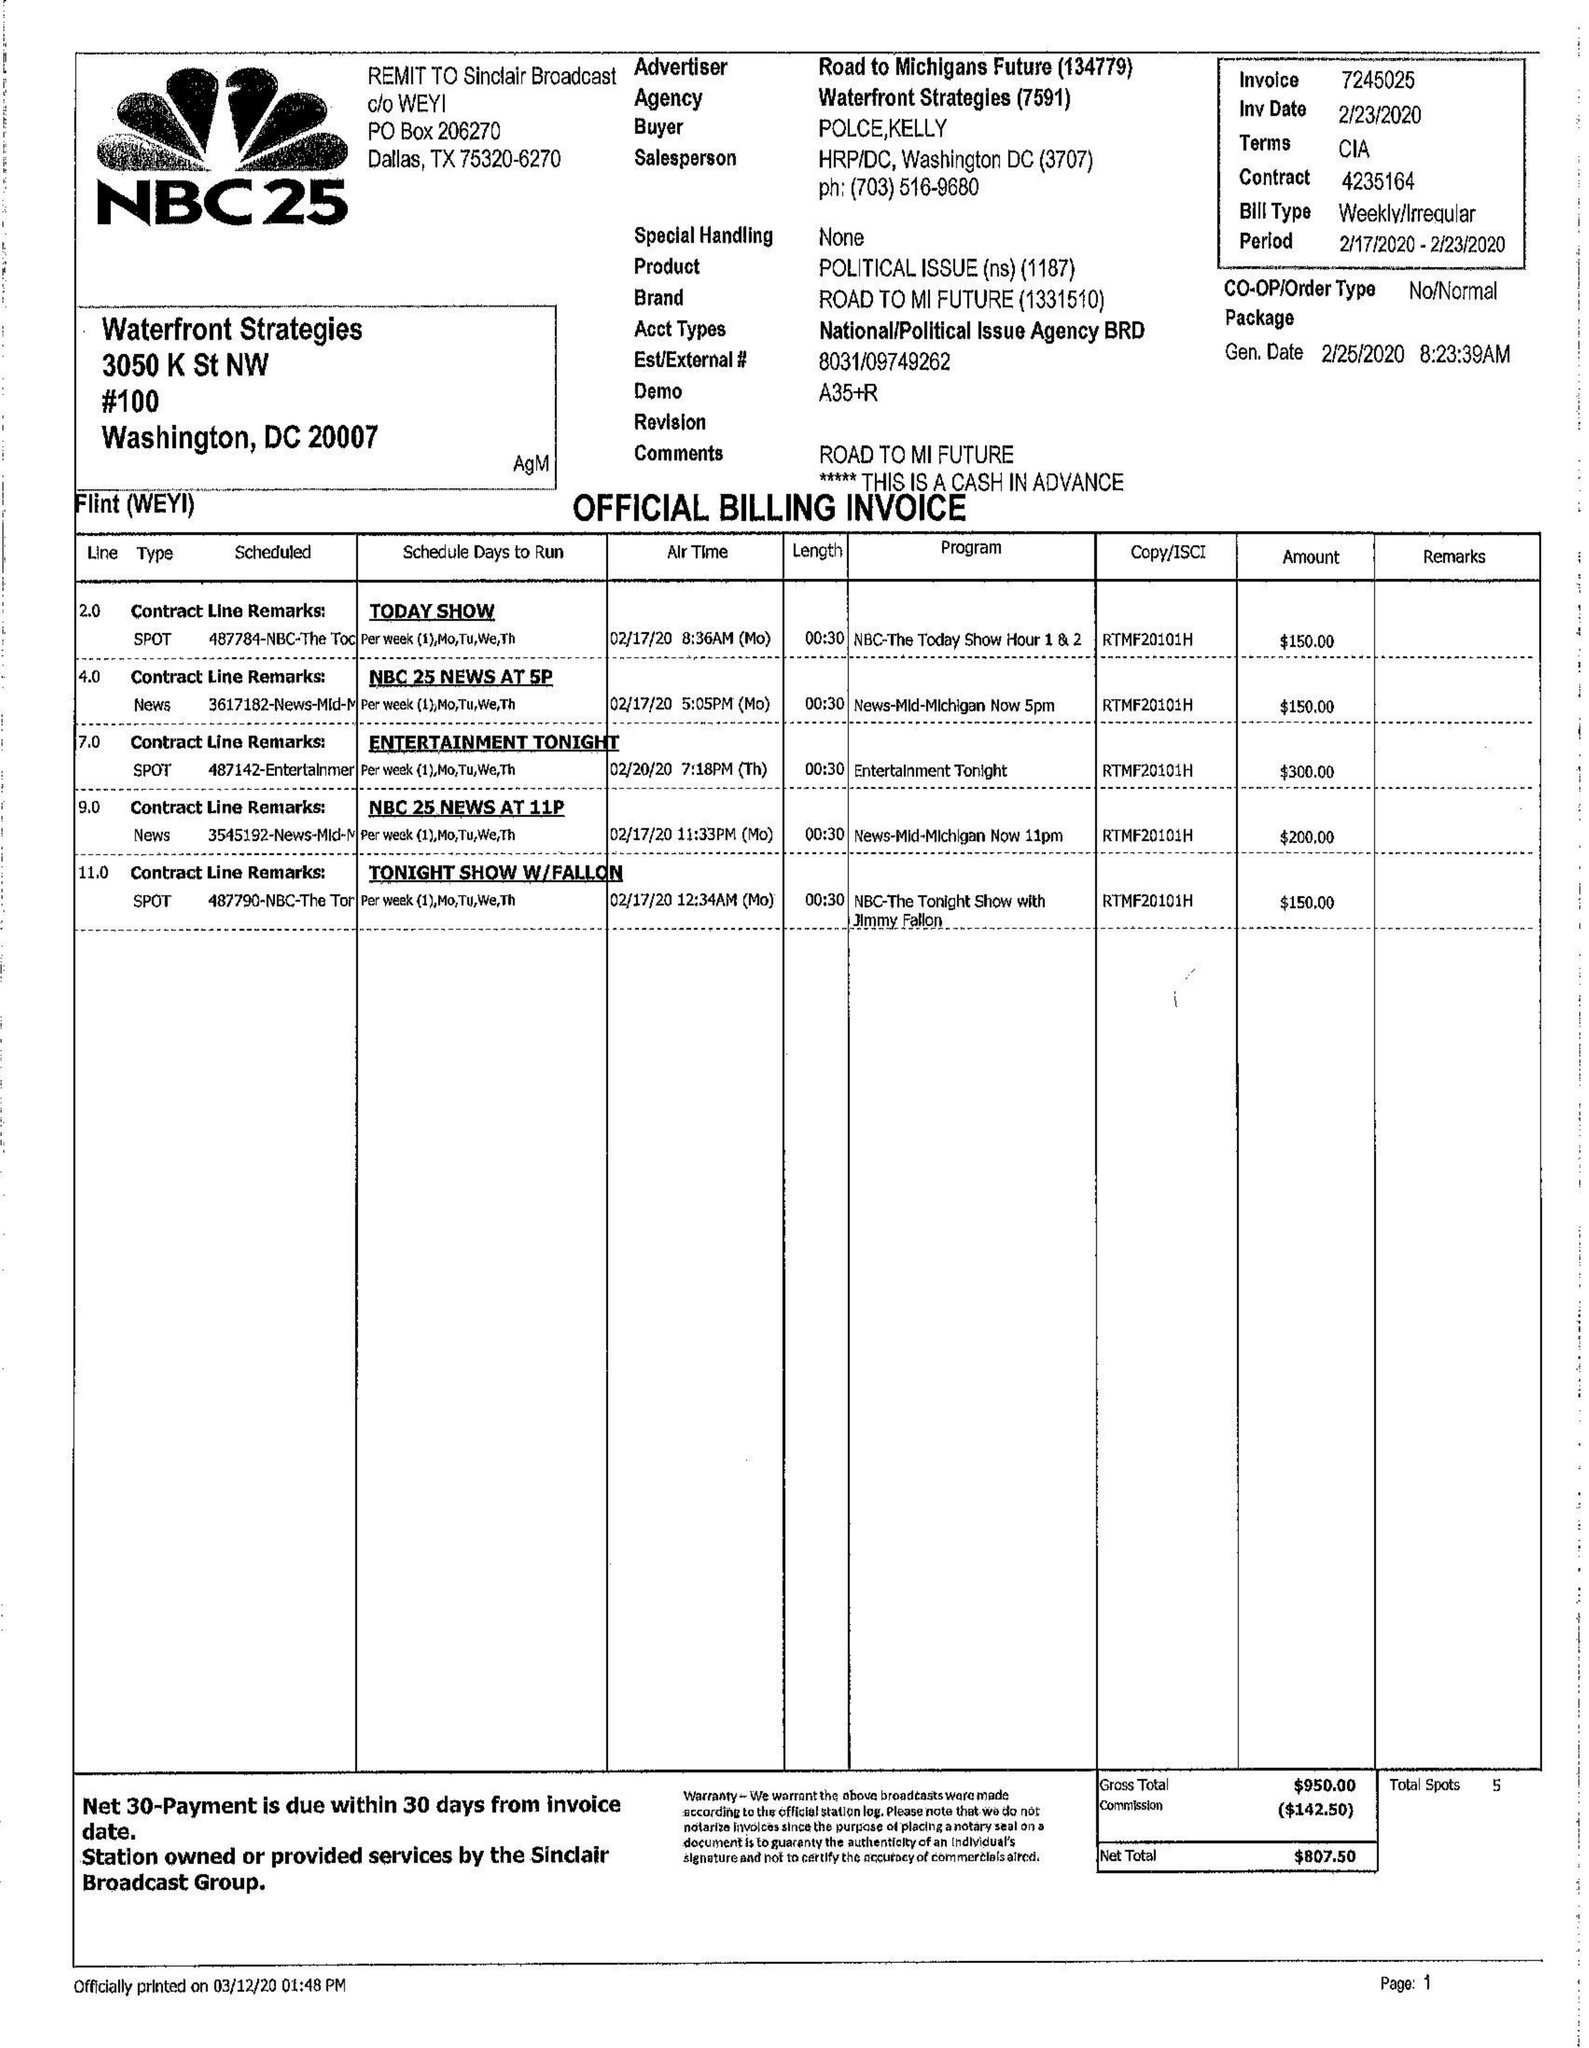What is the value for the contract_num?
Answer the question using a single word or phrase. 4235164 